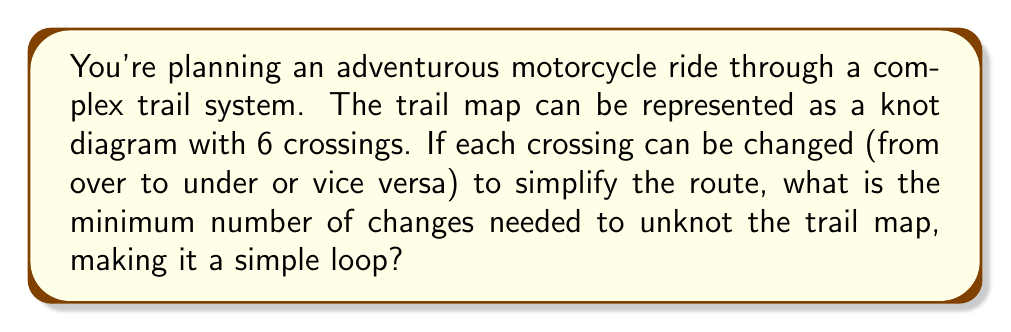Could you help me with this problem? To solve this problem, we need to determine the unknotting number of the given knot representation. The unknotting number is the minimum number of crossing changes required to transform a knot into the unknot (a simple loop).

Step 1: Analyze the given information
- The trail map is represented as a knot diagram with 6 crossings.
- We need to find the minimum number of crossing changes to unknot the diagram.

Step 2: Consider the possible knot types
With 6 crossings, we could have various knot types. The most complex 6-crossing knot is the $6_3$ knot in the Rolfsen table.

Step 3: Determine the unknotting number of the $6_3$ knot
The $6_3$ knot has an unknotting number of 2. This means that even for the most complex 6-crossing knot, we need at most 2 crossing changes to unknot it.

Step 4: Consider simpler 6-crossing knots
Some 6-crossing knots might have an unknotting number of 1, such as the $6_1$ knot.

Step 5: Conclude the answer
Since we don't have specific information about which 6-crossing knot we're dealing with, we must consider the worst-case scenario. Therefore, the maximum unknotting number for any 6-crossing knot is 2.

This means that at most 2 changes to the trail map (changing crossings from over to under or vice versa) will be needed to simplify the route into a simple loop.
Answer: 2 